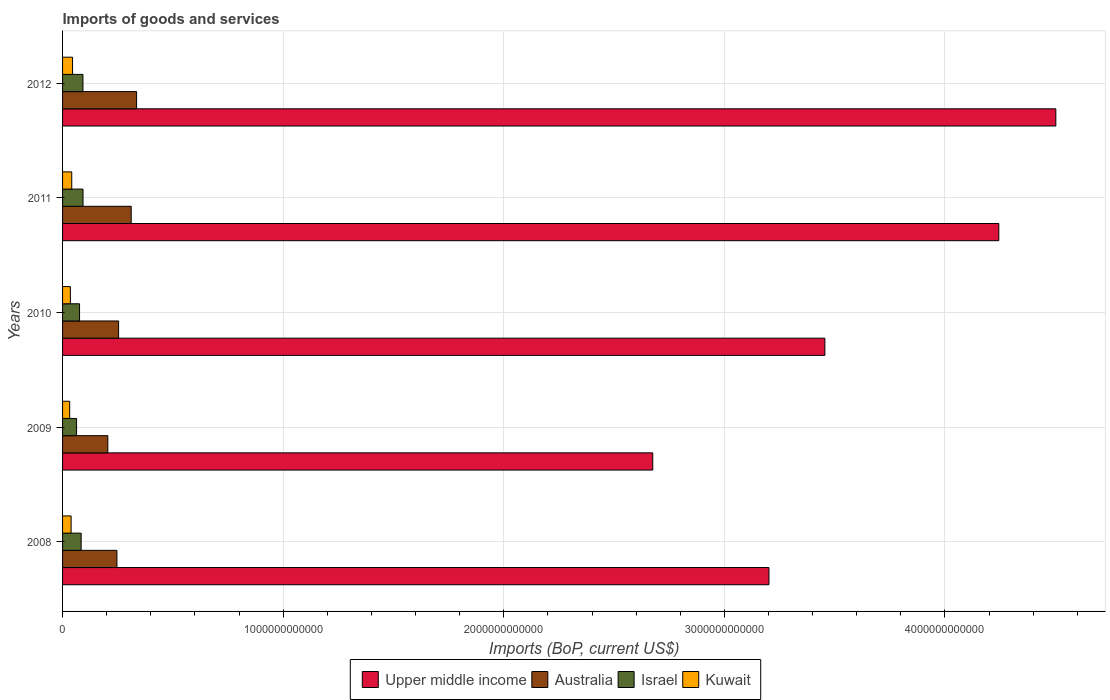How many different coloured bars are there?
Provide a succinct answer. 4. How many groups of bars are there?
Keep it short and to the point. 5. Are the number of bars on each tick of the Y-axis equal?
Your answer should be very brief. Yes. What is the label of the 4th group of bars from the top?
Provide a succinct answer. 2009. In how many cases, is the number of bars for a given year not equal to the number of legend labels?
Give a very brief answer. 0. What is the amount spent on imports in Israel in 2009?
Your response must be concise. 6.35e+1. Across all years, what is the maximum amount spent on imports in Upper middle income?
Your answer should be compact. 4.50e+12. Across all years, what is the minimum amount spent on imports in Israel?
Your answer should be very brief. 6.35e+1. In which year was the amount spent on imports in Australia maximum?
Ensure brevity in your answer.  2012. In which year was the amount spent on imports in Israel minimum?
Keep it short and to the point. 2009. What is the total amount spent on imports in Israel in the graph?
Offer a very short reply. 4.10e+11. What is the difference between the amount spent on imports in Upper middle income in 2009 and that in 2012?
Provide a succinct answer. -1.83e+12. What is the difference between the amount spent on imports in Australia in 2010 and the amount spent on imports in Kuwait in 2012?
Ensure brevity in your answer.  2.09e+11. What is the average amount spent on imports in Australia per year?
Offer a very short reply. 2.70e+11. In the year 2011, what is the difference between the amount spent on imports in Australia and amount spent on imports in Kuwait?
Provide a short and direct response. 2.70e+11. In how many years, is the amount spent on imports in Australia greater than 3400000000000 US$?
Provide a short and direct response. 0. What is the ratio of the amount spent on imports in Australia in 2010 to that in 2012?
Ensure brevity in your answer.  0.76. Is the amount spent on imports in Upper middle income in 2008 less than that in 2009?
Give a very brief answer. No. What is the difference between the highest and the second highest amount spent on imports in Kuwait?
Offer a very short reply. 3.73e+09. What is the difference between the highest and the lowest amount spent on imports in Kuwait?
Make the answer very short. 1.31e+1. In how many years, is the amount spent on imports in Upper middle income greater than the average amount spent on imports in Upper middle income taken over all years?
Keep it short and to the point. 2. What does the 2nd bar from the top in 2010 represents?
Offer a terse response. Israel. What does the 4th bar from the bottom in 2008 represents?
Keep it short and to the point. Kuwait. What is the difference between two consecutive major ticks on the X-axis?
Make the answer very short. 1.00e+12. Are the values on the major ticks of X-axis written in scientific E-notation?
Offer a very short reply. No. Where does the legend appear in the graph?
Ensure brevity in your answer.  Bottom center. How many legend labels are there?
Provide a succinct answer. 4. What is the title of the graph?
Provide a succinct answer. Imports of goods and services. What is the label or title of the X-axis?
Your answer should be compact. Imports (BoP, current US$). What is the label or title of the Y-axis?
Keep it short and to the point. Years. What is the Imports (BoP, current US$) in Upper middle income in 2008?
Ensure brevity in your answer.  3.20e+12. What is the Imports (BoP, current US$) of Australia in 2008?
Provide a succinct answer. 2.46e+11. What is the Imports (BoP, current US$) in Israel in 2008?
Provide a short and direct response. 8.43e+1. What is the Imports (BoP, current US$) of Kuwait in 2008?
Your response must be concise. 3.87e+1. What is the Imports (BoP, current US$) in Upper middle income in 2009?
Provide a succinct answer. 2.68e+12. What is the Imports (BoP, current US$) in Australia in 2009?
Offer a terse response. 2.05e+11. What is the Imports (BoP, current US$) in Israel in 2009?
Keep it short and to the point. 6.35e+1. What is the Imports (BoP, current US$) in Kuwait in 2009?
Provide a succinct answer. 3.23e+1. What is the Imports (BoP, current US$) in Upper middle income in 2010?
Provide a short and direct response. 3.46e+12. What is the Imports (BoP, current US$) of Australia in 2010?
Ensure brevity in your answer.  2.54e+11. What is the Imports (BoP, current US$) in Israel in 2010?
Provide a short and direct response. 7.70e+1. What is the Imports (BoP, current US$) in Kuwait in 2010?
Ensure brevity in your answer.  3.54e+1. What is the Imports (BoP, current US$) in Upper middle income in 2011?
Your response must be concise. 4.24e+12. What is the Imports (BoP, current US$) of Australia in 2011?
Provide a succinct answer. 3.11e+11. What is the Imports (BoP, current US$) of Israel in 2011?
Give a very brief answer. 9.28e+1. What is the Imports (BoP, current US$) of Kuwait in 2011?
Your answer should be very brief. 4.16e+1. What is the Imports (BoP, current US$) of Upper middle income in 2012?
Your response must be concise. 4.50e+12. What is the Imports (BoP, current US$) of Australia in 2012?
Offer a terse response. 3.36e+11. What is the Imports (BoP, current US$) in Israel in 2012?
Give a very brief answer. 9.24e+1. What is the Imports (BoP, current US$) in Kuwait in 2012?
Offer a terse response. 4.53e+1. Across all years, what is the maximum Imports (BoP, current US$) in Upper middle income?
Make the answer very short. 4.50e+12. Across all years, what is the maximum Imports (BoP, current US$) of Australia?
Ensure brevity in your answer.  3.36e+11. Across all years, what is the maximum Imports (BoP, current US$) in Israel?
Provide a succinct answer. 9.28e+1. Across all years, what is the maximum Imports (BoP, current US$) in Kuwait?
Provide a short and direct response. 4.53e+1. Across all years, what is the minimum Imports (BoP, current US$) of Upper middle income?
Ensure brevity in your answer.  2.68e+12. Across all years, what is the minimum Imports (BoP, current US$) in Australia?
Provide a short and direct response. 2.05e+11. Across all years, what is the minimum Imports (BoP, current US$) of Israel?
Keep it short and to the point. 6.35e+1. Across all years, what is the minimum Imports (BoP, current US$) in Kuwait?
Provide a succinct answer. 3.23e+1. What is the total Imports (BoP, current US$) of Upper middle income in the graph?
Offer a very short reply. 1.81e+13. What is the total Imports (BoP, current US$) in Australia in the graph?
Keep it short and to the point. 1.35e+12. What is the total Imports (BoP, current US$) in Israel in the graph?
Ensure brevity in your answer.  4.10e+11. What is the total Imports (BoP, current US$) in Kuwait in the graph?
Offer a very short reply. 1.93e+11. What is the difference between the Imports (BoP, current US$) in Upper middle income in 2008 and that in 2009?
Keep it short and to the point. 5.27e+11. What is the difference between the Imports (BoP, current US$) in Australia in 2008 and that in 2009?
Offer a very short reply. 4.13e+1. What is the difference between the Imports (BoP, current US$) in Israel in 2008 and that in 2009?
Your response must be concise. 2.08e+1. What is the difference between the Imports (BoP, current US$) in Kuwait in 2008 and that in 2009?
Your answer should be very brief. 6.45e+09. What is the difference between the Imports (BoP, current US$) in Upper middle income in 2008 and that in 2010?
Keep it short and to the point. -2.54e+11. What is the difference between the Imports (BoP, current US$) in Australia in 2008 and that in 2010?
Your answer should be very brief. -7.64e+09. What is the difference between the Imports (BoP, current US$) in Israel in 2008 and that in 2010?
Offer a terse response. 7.30e+09. What is the difference between the Imports (BoP, current US$) in Kuwait in 2008 and that in 2010?
Offer a terse response. 3.36e+09. What is the difference between the Imports (BoP, current US$) of Upper middle income in 2008 and that in 2011?
Provide a succinct answer. -1.04e+12. What is the difference between the Imports (BoP, current US$) in Australia in 2008 and that in 2011?
Your answer should be compact. -6.47e+1. What is the difference between the Imports (BoP, current US$) in Israel in 2008 and that in 2011?
Keep it short and to the point. -8.48e+09. What is the difference between the Imports (BoP, current US$) of Kuwait in 2008 and that in 2011?
Provide a succinct answer. -2.89e+09. What is the difference between the Imports (BoP, current US$) of Upper middle income in 2008 and that in 2012?
Ensure brevity in your answer.  -1.30e+12. What is the difference between the Imports (BoP, current US$) in Australia in 2008 and that in 2012?
Your answer should be compact. -8.91e+1. What is the difference between the Imports (BoP, current US$) of Israel in 2008 and that in 2012?
Offer a very short reply. -8.13e+09. What is the difference between the Imports (BoP, current US$) of Kuwait in 2008 and that in 2012?
Offer a very short reply. -6.62e+09. What is the difference between the Imports (BoP, current US$) of Upper middle income in 2009 and that in 2010?
Provide a short and direct response. -7.80e+11. What is the difference between the Imports (BoP, current US$) of Australia in 2009 and that in 2010?
Make the answer very short. -4.89e+1. What is the difference between the Imports (BoP, current US$) in Israel in 2009 and that in 2010?
Ensure brevity in your answer.  -1.35e+1. What is the difference between the Imports (BoP, current US$) in Kuwait in 2009 and that in 2010?
Offer a terse response. -3.08e+09. What is the difference between the Imports (BoP, current US$) of Upper middle income in 2009 and that in 2011?
Give a very brief answer. -1.57e+12. What is the difference between the Imports (BoP, current US$) of Australia in 2009 and that in 2011?
Ensure brevity in your answer.  -1.06e+11. What is the difference between the Imports (BoP, current US$) of Israel in 2009 and that in 2011?
Provide a succinct answer. -2.93e+1. What is the difference between the Imports (BoP, current US$) in Kuwait in 2009 and that in 2011?
Keep it short and to the point. -9.34e+09. What is the difference between the Imports (BoP, current US$) of Upper middle income in 2009 and that in 2012?
Ensure brevity in your answer.  -1.83e+12. What is the difference between the Imports (BoP, current US$) of Australia in 2009 and that in 2012?
Provide a succinct answer. -1.30e+11. What is the difference between the Imports (BoP, current US$) in Israel in 2009 and that in 2012?
Ensure brevity in your answer.  -2.89e+1. What is the difference between the Imports (BoP, current US$) in Kuwait in 2009 and that in 2012?
Make the answer very short. -1.31e+1. What is the difference between the Imports (BoP, current US$) in Upper middle income in 2010 and that in 2011?
Ensure brevity in your answer.  -7.88e+11. What is the difference between the Imports (BoP, current US$) of Australia in 2010 and that in 2011?
Offer a terse response. -5.71e+1. What is the difference between the Imports (BoP, current US$) of Israel in 2010 and that in 2011?
Keep it short and to the point. -1.58e+1. What is the difference between the Imports (BoP, current US$) in Kuwait in 2010 and that in 2011?
Offer a terse response. -6.26e+09. What is the difference between the Imports (BoP, current US$) in Upper middle income in 2010 and that in 2012?
Make the answer very short. -1.05e+12. What is the difference between the Imports (BoP, current US$) in Australia in 2010 and that in 2012?
Provide a succinct answer. -8.15e+1. What is the difference between the Imports (BoP, current US$) in Israel in 2010 and that in 2012?
Offer a terse response. -1.54e+1. What is the difference between the Imports (BoP, current US$) in Kuwait in 2010 and that in 2012?
Your response must be concise. -9.98e+09. What is the difference between the Imports (BoP, current US$) in Upper middle income in 2011 and that in 2012?
Provide a succinct answer. -2.58e+11. What is the difference between the Imports (BoP, current US$) in Australia in 2011 and that in 2012?
Provide a succinct answer. -2.44e+1. What is the difference between the Imports (BoP, current US$) in Israel in 2011 and that in 2012?
Offer a very short reply. 3.53e+08. What is the difference between the Imports (BoP, current US$) of Kuwait in 2011 and that in 2012?
Provide a succinct answer. -3.73e+09. What is the difference between the Imports (BoP, current US$) in Upper middle income in 2008 and the Imports (BoP, current US$) in Australia in 2009?
Offer a terse response. 3.00e+12. What is the difference between the Imports (BoP, current US$) in Upper middle income in 2008 and the Imports (BoP, current US$) in Israel in 2009?
Your answer should be compact. 3.14e+12. What is the difference between the Imports (BoP, current US$) in Upper middle income in 2008 and the Imports (BoP, current US$) in Kuwait in 2009?
Offer a very short reply. 3.17e+12. What is the difference between the Imports (BoP, current US$) in Australia in 2008 and the Imports (BoP, current US$) in Israel in 2009?
Provide a short and direct response. 1.83e+11. What is the difference between the Imports (BoP, current US$) in Australia in 2008 and the Imports (BoP, current US$) in Kuwait in 2009?
Ensure brevity in your answer.  2.14e+11. What is the difference between the Imports (BoP, current US$) in Israel in 2008 and the Imports (BoP, current US$) in Kuwait in 2009?
Offer a very short reply. 5.20e+1. What is the difference between the Imports (BoP, current US$) of Upper middle income in 2008 and the Imports (BoP, current US$) of Australia in 2010?
Provide a short and direct response. 2.95e+12. What is the difference between the Imports (BoP, current US$) of Upper middle income in 2008 and the Imports (BoP, current US$) of Israel in 2010?
Your response must be concise. 3.13e+12. What is the difference between the Imports (BoP, current US$) in Upper middle income in 2008 and the Imports (BoP, current US$) in Kuwait in 2010?
Make the answer very short. 3.17e+12. What is the difference between the Imports (BoP, current US$) in Australia in 2008 and the Imports (BoP, current US$) in Israel in 2010?
Give a very brief answer. 1.69e+11. What is the difference between the Imports (BoP, current US$) in Australia in 2008 and the Imports (BoP, current US$) in Kuwait in 2010?
Offer a terse response. 2.11e+11. What is the difference between the Imports (BoP, current US$) in Israel in 2008 and the Imports (BoP, current US$) in Kuwait in 2010?
Provide a short and direct response. 4.89e+1. What is the difference between the Imports (BoP, current US$) of Upper middle income in 2008 and the Imports (BoP, current US$) of Australia in 2011?
Your response must be concise. 2.89e+12. What is the difference between the Imports (BoP, current US$) in Upper middle income in 2008 and the Imports (BoP, current US$) in Israel in 2011?
Provide a succinct answer. 3.11e+12. What is the difference between the Imports (BoP, current US$) of Upper middle income in 2008 and the Imports (BoP, current US$) of Kuwait in 2011?
Your answer should be compact. 3.16e+12. What is the difference between the Imports (BoP, current US$) in Australia in 2008 and the Imports (BoP, current US$) in Israel in 2011?
Provide a short and direct response. 1.54e+11. What is the difference between the Imports (BoP, current US$) in Australia in 2008 and the Imports (BoP, current US$) in Kuwait in 2011?
Make the answer very short. 2.05e+11. What is the difference between the Imports (BoP, current US$) of Israel in 2008 and the Imports (BoP, current US$) of Kuwait in 2011?
Give a very brief answer. 4.27e+1. What is the difference between the Imports (BoP, current US$) of Upper middle income in 2008 and the Imports (BoP, current US$) of Australia in 2012?
Your answer should be very brief. 2.87e+12. What is the difference between the Imports (BoP, current US$) of Upper middle income in 2008 and the Imports (BoP, current US$) of Israel in 2012?
Make the answer very short. 3.11e+12. What is the difference between the Imports (BoP, current US$) of Upper middle income in 2008 and the Imports (BoP, current US$) of Kuwait in 2012?
Make the answer very short. 3.16e+12. What is the difference between the Imports (BoP, current US$) in Australia in 2008 and the Imports (BoP, current US$) in Israel in 2012?
Provide a succinct answer. 1.54e+11. What is the difference between the Imports (BoP, current US$) of Australia in 2008 and the Imports (BoP, current US$) of Kuwait in 2012?
Give a very brief answer. 2.01e+11. What is the difference between the Imports (BoP, current US$) in Israel in 2008 and the Imports (BoP, current US$) in Kuwait in 2012?
Keep it short and to the point. 3.89e+1. What is the difference between the Imports (BoP, current US$) in Upper middle income in 2009 and the Imports (BoP, current US$) in Australia in 2010?
Make the answer very short. 2.42e+12. What is the difference between the Imports (BoP, current US$) of Upper middle income in 2009 and the Imports (BoP, current US$) of Israel in 2010?
Your answer should be very brief. 2.60e+12. What is the difference between the Imports (BoP, current US$) in Upper middle income in 2009 and the Imports (BoP, current US$) in Kuwait in 2010?
Offer a very short reply. 2.64e+12. What is the difference between the Imports (BoP, current US$) of Australia in 2009 and the Imports (BoP, current US$) of Israel in 2010?
Provide a short and direct response. 1.28e+11. What is the difference between the Imports (BoP, current US$) of Australia in 2009 and the Imports (BoP, current US$) of Kuwait in 2010?
Provide a short and direct response. 1.70e+11. What is the difference between the Imports (BoP, current US$) in Israel in 2009 and the Imports (BoP, current US$) in Kuwait in 2010?
Your response must be concise. 2.82e+1. What is the difference between the Imports (BoP, current US$) of Upper middle income in 2009 and the Imports (BoP, current US$) of Australia in 2011?
Give a very brief answer. 2.36e+12. What is the difference between the Imports (BoP, current US$) of Upper middle income in 2009 and the Imports (BoP, current US$) of Israel in 2011?
Your answer should be compact. 2.58e+12. What is the difference between the Imports (BoP, current US$) of Upper middle income in 2009 and the Imports (BoP, current US$) of Kuwait in 2011?
Make the answer very short. 2.63e+12. What is the difference between the Imports (BoP, current US$) in Australia in 2009 and the Imports (BoP, current US$) in Israel in 2011?
Provide a short and direct response. 1.12e+11. What is the difference between the Imports (BoP, current US$) of Australia in 2009 and the Imports (BoP, current US$) of Kuwait in 2011?
Ensure brevity in your answer.  1.64e+11. What is the difference between the Imports (BoP, current US$) of Israel in 2009 and the Imports (BoP, current US$) of Kuwait in 2011?
Make the answer very short. 2.19e+1. What is the difference between the Imports (BoP, current US$) of Upper middle income in 2009 and the Imports (BoP, current US$) of Australia in 2012?
Your answer should be compact. 2.34e+12. What is the difference between the Imports (BoP, current US$) in Upper middle income in 2009 and the Imports (BoP, current US$) in Israel in 2012?
Your answer should be very brief. 2.58e+12. What is the difference between the Imports (BoP, current US$) of Upper middle income in 2009 and the Imports (BoP, current US$) of Kuwait in 2012?
Your response must be concise. 2.63e+12. What is the difference between the Imports (BoP, current US$) of Australia in 2009 and the Imports (BoP, current US$) of Israel in 2012?
Provide a short and direct response. 1.13e+11. What is the difference between the Imports (BoP, current US$) in Australia in 2009 and the Imports (BoP, current US$) in Kuwait in 2012?
Your answer should be very brief. 1.60e+11. What is the difference between the Imports (BoP, current US$) in Israel in 2009 and the Imports (BoP, current US$) in Kuwait in 2012?
Provide a short and direct response. 1.82e+1. What is the difference between the Imports (BoP, current US$) of Upper middle income in 2010 and the Imports (BoP, current US$) of Australia in 2011?
Provide a short and direct response. 3.14e+12. What is the difference between the Imports (BoP, current US$) in Upper middle income in 2010 and the Imports (BoP, current US$) in Israel in 2011?
Give a very brief answer. 3.36e+12. What is the difference between the Imports (BoP, current US$) of Upper middle income in 2010 and the Imports (BoP, current US$) of Kuwait in 2011?
Make the answer very short. 3.41e+12. What is the difference between the Imports (BoP, current US$) in Australia in 2010 and the Imports (BoP, current US$) in Israel in 2011?
Provide a succinct answer. 1.61e+11. What is the difference between the Imports (BoP, current US$) in Australia in 2010 and the Imports (BoP, current US$) in Kuwait in 2011?
Ensure brevity in your answer.  2.12e+11. What is the difference between the Imports (BoP, current US$) of Israel in 2010 and the Imports (BoP, current US$) of Kuwait in 2011?
Keep it short and to the point. 3.54e+1. What is the difference between the Imports (BoP, current US$) of Upper middle income in 2010 and the Imports (BoP, current US$) of Australia in 2012?
Make the answer very short. 3.12e+12. What is the difference between the Imports (BoP, current US$) of Upper middle income in 2010 and the Imports (BoP, current US$) of Israel in 2012?
Ensure brevity in your answer.  3.36e+12. What is the difference between the Imports (BoP, current US$) in Upper middle income in 2010 and the Imports (BoP, current US$) in Kuwait in 2012?
Make the answer very short. 3.41e+12. What is the difference between the Imports (BoP, current US$) in Australia in 2010 and the Imports (BoP, current US$) in Israel in 2012?
Your answer should be compact. 1.62e+11. What is the difference between the Imports (BoP, current US$) of Australia in 2010 and the Imports (BoP, current US$) of Kuwait in 2012?
Your response must be concise. 2.09e+11. What is the difference between the Imports (BoP, current US$) in Israel in 2010 and the Imports (BoP, current US$) in Kuwait in 2012?
Ensure brevity in your answer.  3.16e+1. What is the difference between the Imports (BoP, current US$) of Upper middle income in 2011 and the Imports (BoP, current US$) of Australia in 2012?
Ensure brevity in your answer.  3.91e+12. What is the difference between the Imports (BoP, current US$) of Upper middle income in 2011 and the Imports (BoP, current US$) of Israel in 2012?
Offer a very short reply. 4.15e+12. What is the difference between the Imports (BoP, current US$) in Upper middle income in 2011 and the Imports (BoP, current US$) in Kuwait in 2012?
Offer a very short reply. 4.20e+12. What is the difference between the Imports (BoP, current US$) in Australia in 2011 and the Imports (BoP, current US$) in Israel in 2012?
Provide a short and direct response. 2.19e+11. What is the difference between the Imports (BoP, current US$) of Australia in 2011 and the Imports (BoP, current US$) of Kuwait in 2012?
Your answer should be very brief. 2.66e+11. What is the difference between the Imports (BoP, current US$) in Israel in 2011 and the Imports (BoP, current US$) in Kuwait in 2012?
Provide a succinct answer. 4.74e+1. What is the average Imports (BoP, current US$) in Upper middle income per year?
Your answer should be compact. 3.62e+12. What is the average Imports (BoP, current US$) in Australia per year?
Offer a very short reply. 2.70e+11. What is the average Imports (BoP, current US$) of Israel per year?
Give a very brief answer. 8.20e+1. What is the average Imports (BoP, current US$) in Kuwait per year?
Keep it short and to the point. 3.87e+1. In the year 2008, what is the difference between the Imports (BoP, current US$) of Upper middle income and Imports (BoP, current US$) of Australia?
Keep it short and to the point. 2.96e+12. In the year 2008, what is the difference between the Imports (BoP, current US$) of Upper middle income and Imports (BoP, current US$) of Israel?
Your answer should be very brief. 3.12e+12. In the year 2008, what is the difference between the Imports (BoP, current US$) of Upper middle income and Imports (BoP, current US$) of Kuwait?
Keep it short and to the point. 3.16e+12. In the year 2008, what is the difference between the Imports (BoP, current US$) of Australia and Imports (BoP, current US$) of Israel?
Give a very brief answer. 1.62e+11. In the year 2008, what is the difference between the Imports (BoP, current US$) in Australia and Imports (BoP, current US$) in Kuwait?
Make the answer very short. 2.08e+11. In the year 2008, what is the difference between the Imports (BoP, current US$) in Israel and Imports (BoP, current US$) in Kuwait?
Your response must be concise. 4.56e+1. In the year 2009, what is the difference between the Imports (BoP, current US$) in Upper middle income and Imports (BoP, current US$) in Australia?
Make the answer very short. 2.47e+12. In the year 2009, what is the difference between the Imports (BoP, current US$) in Upper middle income and Imports (BoP, current US$) in Israel?
Keep it short and to the point. 2.61e+12. In the year 2009, what is the difference between the Imports (BoP, current US$) of Upper middle income and Imports (BoP, current US$) of Kuwait?
Make the answer very short. 2.64e+12. In the year 2009, what is the difference between the Imports (BoP, current US$) of Australia and Imports (BoP, current US$) of Israel?
Your answer should be very brief. 1.42e+11. In the year 2009, what is the difference between the Imports (BoP, current US$) of Australia and Imports (BoP, current US$) of Kuwait?
Provide a short and direct response. 1.73e+11. In the year 2009, what is the difference between the Imports (BoP, current US$) in Israel and Imports (BoP, current US$) in Kuwait?
Offer a terse response. 3.12e+1. In the year 2010, what is the difference between the Imports (BoP, current US$) in Upper middle income and Imports (BoP, current US$) in Australia?
Provide a short and direct response. 3.20e+12. In the year 2010, what is the difference between the Imports (BoP, current US$) of Upper middle income and Imports (BoP, current US$) of Israel?
Provide a short and direct response. 3.38e+12. In the year 2010, what is the difference between the Imports (BoP, current US$) in Upper middle income and Imports (BoP, current US$) in Kuwait?
Make the answer very short. 3.42e+12. In the year 2010, what is the difference between the Imports (BoP, current US$) of Australia and Imports (BoP, current US$) of Israel?
Offer a very short reply. 1.77e+11. In the year 2010, what is the difference between the Imports (BoP, current US$) in Australia and Imports (BoP, current US$) in Kuwait?
Make the answer very short. 2.19e+11. In the year 2010, what is the difference between the Imports (BoP, current US$) of Israel and Imports (BoP, current US$) of Kuwait?
Give a very brief answer. 4.16e+1. In the year 2011, what is the difference between the Imports (BoP, current US$) of Upper middle income and Imports (BoP, current US$) of Australia?
Make the answer very short. 3.93e+12. In the year 2011, what is the difference between the Imports (BoP, current US$) of Upper middle income and Imports (BoP, current US$) of Israel?
Your answer should be compact. 4.15e+12. In the year 2011, what is the difference between the Imports (BoP, current US$) in Upper middle income and Imports (BoP, current US$) in Kuwait?
Your answer should be compact. 4.20e+12. In the year 2011, what is the difference between the Imports (BoP, current US$) of Australia and Imports (BoP, current US$) of Israel?
Make the answer very short. 2.18e+11. In the year 2011, what is the difference between the Imports (BoP, current US$) in Australia and Imports (BoP, current US$) in Kuwait?
Give a very brief answer. 2.70e+11. In the year 2011, what is the difference between the Imports (BoP, current US$) of Israel and Imports (BoP, current US$) of Kuwait?
Make the answer very short. 5.12e+1. In the year 2012, what is the difference between the Imports (BoP, current US$) in Upper middle income and Imports (BoP, current US$) in Australia?
Offer a very short reply. 4.17e+12. In the year 2012, what is the difference between the Imports (BoP, current US$) in Upper middle income and Imports (BoP, current US$) in Israel?
Keep it short and to the point. 4.41e+12. In the year 2012, what is the difference between the Imports (BoP, current US$) of Upper middle income and Imports (BoP, current US$) of Kuwait?
Your response must be concise. 4.46e+12. In the year 2012, what is the difference between the Imports (BoP, current US$) in Australia and Imports (BoP, current US$) in Israel?
Offer a very short reply. 2.43e+11. In the year 2012, what is the difference between the Imports (BoP, current US$) of Australia and Imports (BoP, current US$) of Kuwait?
Your response must be concise. 2.90e+11. In the year 2012, what is the difference between the Imports (BoP, current US$) of Israel and Imports (BoP, current US$) of Kuwait?
Keep it short and to the point. 4.71e+1. What is the ratio of the Imports (BoP, current US$) of Upper middle income in 2008 to that in 2009?
Give a very brief answer. 1.2. What is the ratio of the Imports (BoP, current US$) in Australia in 2008 to that in 2009?
Make the answer very short. 1.2. What is the ratio of the Imports (BoP, current US$) in Israel in 2008 to that in 2009?
Provide a short and direct response. 1.33. What is the ratio of the Imports (BoP, current US$) of Kuwait in 2008 to that in 2009?
Offer a terse response. 1.2. What is the ratio of the Imports (BoP, current US$) in Upper middle income in 2008 to that in 2010?
Give a very brief answer. 0.93. What is the ratio of the Imports (BoP, current US$) of Australia in 2008 to that in 2010?
Provide a short and direct response. 0.97. What is the ratio of the Imports (BoP, current US$) in Israel in 2008 to that in 2010?
Give a very brief answer. 1.09. What is the ratio of the Imports (BoP, current US$) in Kuwait in 2008 to that in 2010?
Provide a short and direct response. 1.1. What is the ratio of the Imports (BoP, current US$) in Upper middle income in 2008 to that in 2011?
Your response must be concise. 0.75. What is the ratio of the Imports (BoP, current US$) in Australia in 2008 to that in 2011?
Provide a succinct answer. 0.79. What is the ratio of the Imports (BoP, current US$) of Israel in 2008 to that in 2011?
Give a very brief answer. 0.91. What is the ratio of the Imports (BoP, current US$) in Kuwait in 2008 to that in 2011?
Keep it short and to the point. 0.93. What is the ratio of the Imports (BoP, current US$) in Upper middle income in 2008 to that in 2012?
Ensure brevity in your answer.  0.71. What is the ratio of the Imports (BoP, current US$) of Australia in 2008 to that in 2012?
Ensure brevity in your answer.  0.73. What is the ratio of the Imports (BoP, current US$) of Israel in 2008 to that in 2012?
Provide a short and direct response. 0.91. What is the ratio of the Imports (BoP, current US$) of Kuwait in 2008 to that in 2012?
Your answer should be very brief. 0.85. What is the ratio of the Imports (BoP, current US$) of Upper middle income in 2009 to that in 2010?
Give a very brief answer. 0.77. What is the ratio of the Imports (BoP, current US$) in Australia in 2009 to that in 2010?
Keep it short and to the point. 0.81. What is the ratio of the Imports (BoP, current US$) in Israel in 2009 to that in 2010?
Ensure brevity in your answer.  0.82. What is the ratio of the Imports (BoP, current US$) in Kuwait in 2009 to that in 2010?
Offer a very short reply. 0.91. What is the ratio of the Imports (BoP, current US$) in Upper middle income in 2009 to that in 2011?
Ensure brevity in your answer.  0.63. What is the ratio of the Imports (BoP, current US$) in Australia in 2009 to that in 2011?
Your answer should be very brief. 0.66. What is the ratio of the Imports (BoP, current US$) of Israel in 2009 to that in 2011?
Provide a succinct answer. 0.68. What is the ratio of the Imports (BoP, current US$) of Kuwait in 2009 to that in 2011?
Give a very brief answer. 0.78. What is the ratio of the Imports (BoP, current US$) in Upper middle income in 2009 to that in 2012?
Offer a very short reply. 0.59. What is the ratio of the Imports (BoP, current US$) in Australia in 2009 to that in 2012?
Your answer should be compact. 0.61. What is the ratio of the Imports (BoP, current US$) in Israel in 2009 to that in 2012?
Ensure brevity in your answer.  0.69. What is the ratio of the Imports (BoP, current US$) of Kuwait in 2009 to that in 2012?
Offer a very short reply. 0.71. What is the ratio of the Imports (BoP, current US$) of Upper middle income in 2010 to that in 2011?
Offer a very short reply. 0.81. What is the ratio of the Imports (BoP, current US$) of Australia in 2010 to that in 2011?
Give a very brief answer. 0.82. What is the ratio of the Imports (BoP, current US$) in Israel in 2010 to that in 2011?
Make the answer very short. 0.83. What is the ratio of the Imports (BoP, current US$) in Kuwait in 2010 to that in 2011?
Keep it short and to the point. 0.85. What is the ratio of the Imports (BoP, current US$) of Upper middle income in 2010 to that in 2012?
Make the answer very short. 0.77. What is the ratio of the Imports (BoP, current US$) of Australia in 2010 to that in 2012?
Make the answer very short. 0.76. What is the ratio of the Imports (BoP, current US$) of Israel in 2010 to that in 2012?
Make the answer very short. 0.83. What is the ratio of the Imports (BoP, current US$) in Kuwait in 2010 to that in 2012?
Your response must be concise. 0.78. What is the ratio of the Imports (BoP, current US$) of Upper middle income in 2011 to that in 2012?
Your response must be concise. 0.94. What is the ratio of the Imports (BoP, current US$) in Australia in 2011 to that in 2012?
Make the answer very short. 0.93. What is the ratio of the Imports (BoP, current US$) in Kuwait in 2011 to that in 2012?
Ensure brevity in your answer.  0.92. What is the difference between the highest and the second highest Imports (BoP, current US$) of Upper middle income?
Your response must be concise. 2.58e+11. What is the difference between the highest and the second highest Imports (BoP, current US$) of Australia?
Keep it short and to the point. 2.44e+1. What is the difference between the highest and the second highest Imports (BoP, current US$) of Israel?
Your answer should be very brief. 3.53e+08. What is the difference between the highest and the second highest Imports (BoP, current US$) in Kuwait?
Offer a very short reply. 3.73e+09. What is the difference between the highest and the lowest Imports (BoP, current US$) of Upper middle income?
Keep it short and to the point. 1.83e+12. What is the difference between the highest and the lowest Imports (BoP, current US$) of Australia?
Ensure brevity in your answer.  1.30e+11. What is the difference between the highest and the lowest Imports (BoP, current US$) of Israel?
Your answer should be very brief. 2.93e+1. What is the difference between the highest and the lowest Imports (BoP, current US$) of Kuwait?
Keep it short and to the point. 1.31e+1. 